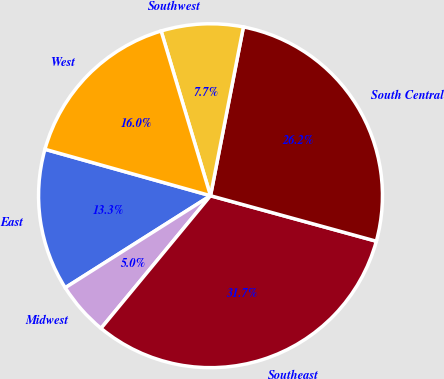<chart> <loc_0><loc_0><loc_500><loc_500><pie_chart><fcel>East<fcel>Midwest<fcel>Southeast<fcel>South Central<fcel>Southwest<fcel>West<nl><fcel>13.34%<fcel>5.03%<fcel>31.72%<fcel>26.2%<fcel>7.7%<fcel>16.01%<nl></chart> 